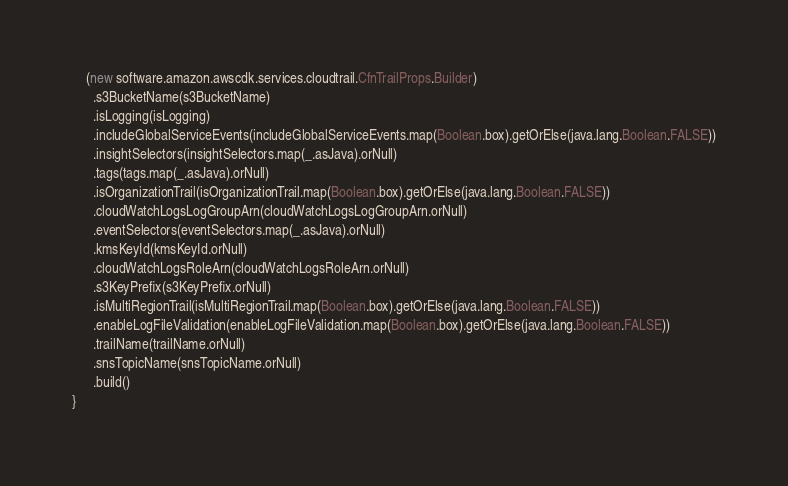<code> <loc_0><loc_0><loc_500><loc_500><_Scala_>    (new software.amazon.awscdk.services.cloudtrail.CfnTrailProps.Builder)
      .s3BucketName(s3BucketName)
      .isLogging(isLogging)
      .includeGlobalServiceEvents(includeGlobalServiceEvents.map(Boolean.box).getOrElse(java.lang.Boolean.FALSE))
      .insightSelectors(insightSelectors.map(_.asJava).orNull)
      .tags(tags.map(_.asJava).orNull)
      .isOrganizationTrail(isOrganizationTrail.map(Boolean.box).getOrElse(java.lang.Boolean.FALSE))
      .cloudWatchLogsLogGroupArn(cloudWatchLogsLogGroupArn.orNull)
      .eventSelectors(eventSelectors.map(_.asJava).orNull)
      .kmsKeyId(kmsKeyId.orNull)
      .cloudWatchLogsRoleArn(cloudWatchLogsRoleArn.orNull)
      .s3KeyPrefix(s3KeyPrefix.orNull)
      .isMultiRegionTrail(isMultiRegionTrail.map(Boolean.box).getOrElse(java.lang.Boolean.FALSE))
      .enableLogFileValidation(enableLogFileValidation.map(Boolean.box).getOrElse(java.lang.Boolean.FALSE))
      .trailName(trailName.orNull)
      .snsTopicName(snsTopicName.orNull)
      .build()
}
</code> 